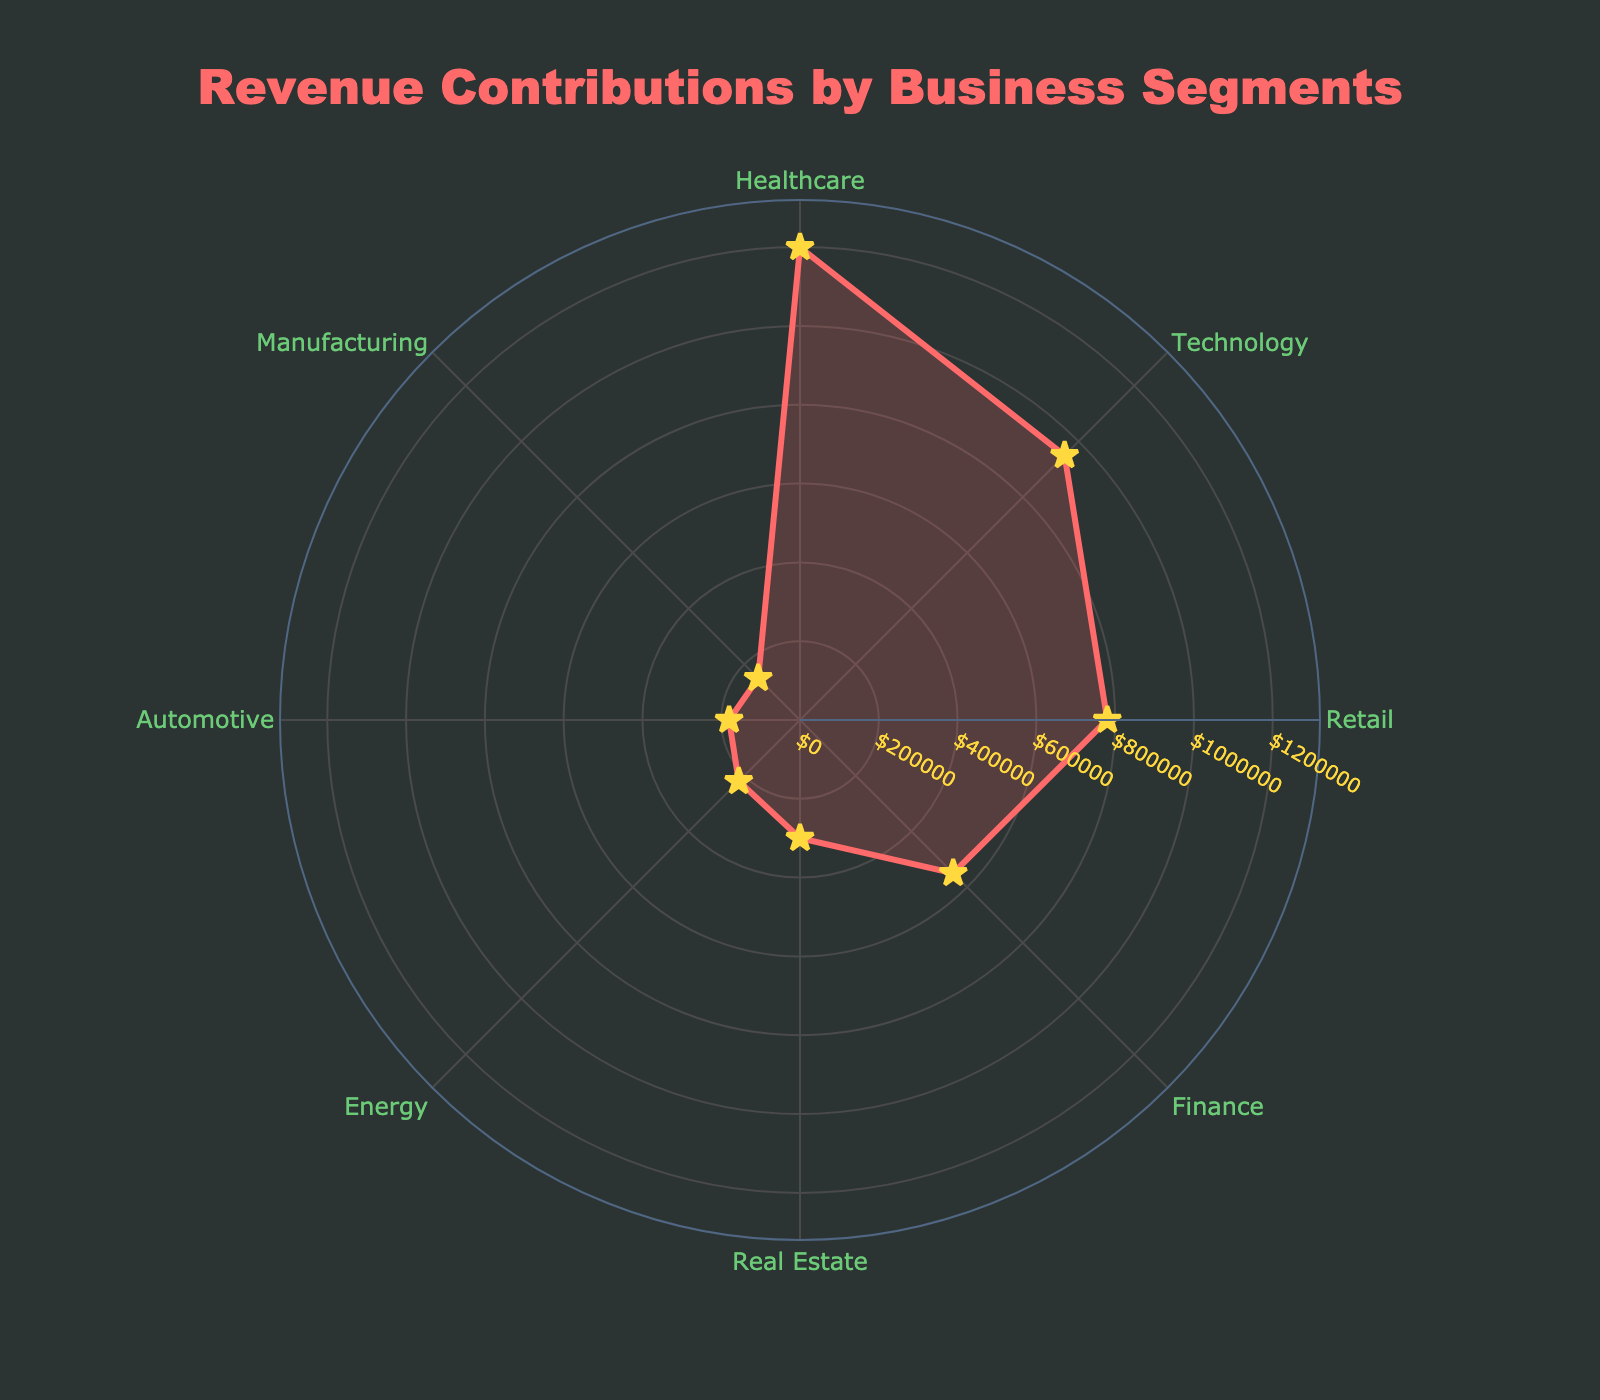What is the title of the chart? The title of the chart is prominently displayed at the top of the figure. It reads as 'Revenue Contributions by Business Segments'.
Answer: Revenue Contributions by Business Segments Which business segment has the highest revenue contribution? The segment with the highest revenue contribution is found at the point with the maximum value on the radial axis. The Healthcare segment has the highest revenue contribution.
Answer: Healthcare How many business segments are shown in the chart? By counting the unique segments around the circular axis labeled 'Segment', we can determine the total number. There are 8 business segments shown in the chart.
Answer: 8 What is the revenue contribution of the Finance segment? By locating the Finance segment along the circular axis and tracing its radial value, we find that the Finance segment's revenue contribution is $550,000.
Answer: $550,000 What color is used to represent the revenue lines on the chart? The color of the revenue lines can be observed from the radial line. The lines are represented in a shade of red.
Answer: Red Which segment has a revenue contribution closest to $800,000? To find the segment with a revenue contribution closest to $800,000, we observe the radial lines and markers to identify the nearest value. The Retail segment has a contribution of $780,000, which is closest to $800,000.
Answer: Retail What is the combined revenue contribution of the Technology and Retail segments? The revenue of the Technology segment is $950,000 and the Retail segment is $780,000. Summing these values: $950,000 + $780,000 = $1,730,000.
Answer: $1,730,000 Which segment has the least revenue contribution and how much is it? The segment with the smallest radial value is the one with the least revenue. From the chart, the Automotive segment has the lowest revenue contribution of $180,000.
Answer: Automotive, $180,000 How does the revenue contribution of the Real Estate segment compare to the Healthcare segment? Looking at the radial values, Healthcare is at $1,200,000 while Real Estate is at $300,000. Thus, Real Estate contributes less by a significant margin.
Answer: Real Estate contributes less What shapes are used to mark the data points on the chart? The shapes used to mark the data points on the radial lines of the chart are star symbols.
Answer: Star symbols 